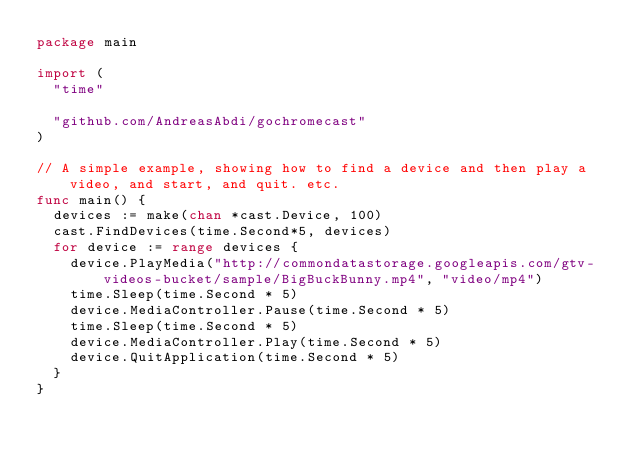Convert code to text. <code><loc_0><loc_0><loc_500><loc_500><_Go_>package main

import (
	"time"

	"github.com/AndreasAbdi/gochromecast"
)

// A simple example, showing how to find a device and then play a video, and start, and quit. etc.
func main() {
	devices := make(chan *cast.Device, 100)
	cast.FindDevices(time.Second*5, devices)
	for device := range devices {
		device.PlayMedia("http://commondatastorage.googleapis.com/gtv-videos-bucket/sample/BigBuckBunny.mp4", "video/mp4")
		time.Sleep(time.Second * 5)
		device.MediaController.Pause(time.Second * 5)
		time.Sleep(time.Second * 5)
		device.MediaController.Play(time.Second * 5)
		device.QuitApplication(time.Second * 5)
	}
}
</code> 